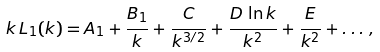<formula> <loc_0><loc_0><loc_500><loc_500>k \, L _ { 1 } ( k ) = A _ { 1 } + \frac { B _ { 1 } } { k } + \frac { C } { k ^ { 3 / 2 } } + \frac { D \, \ln k } { k ^ { 2 } } + \frac { E } { k ^ { 2 } } + \dots \, ,</formula> 